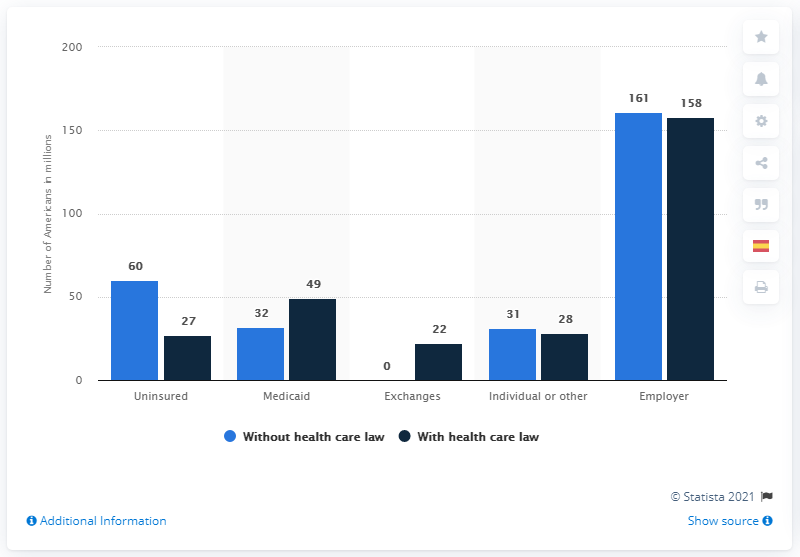Highlight a few significant elements in this photo. According to recent estimates, the current population of uninsured Americans is approximately 60 million. The value of health care coverage without the Affordable Care Act is 0%, and the factor of it is the lack of access to essential health benefits and protections for millions of Americans. The color bar with the highest value is blue. Approximately 27% of Americans are currently without health insurance. 